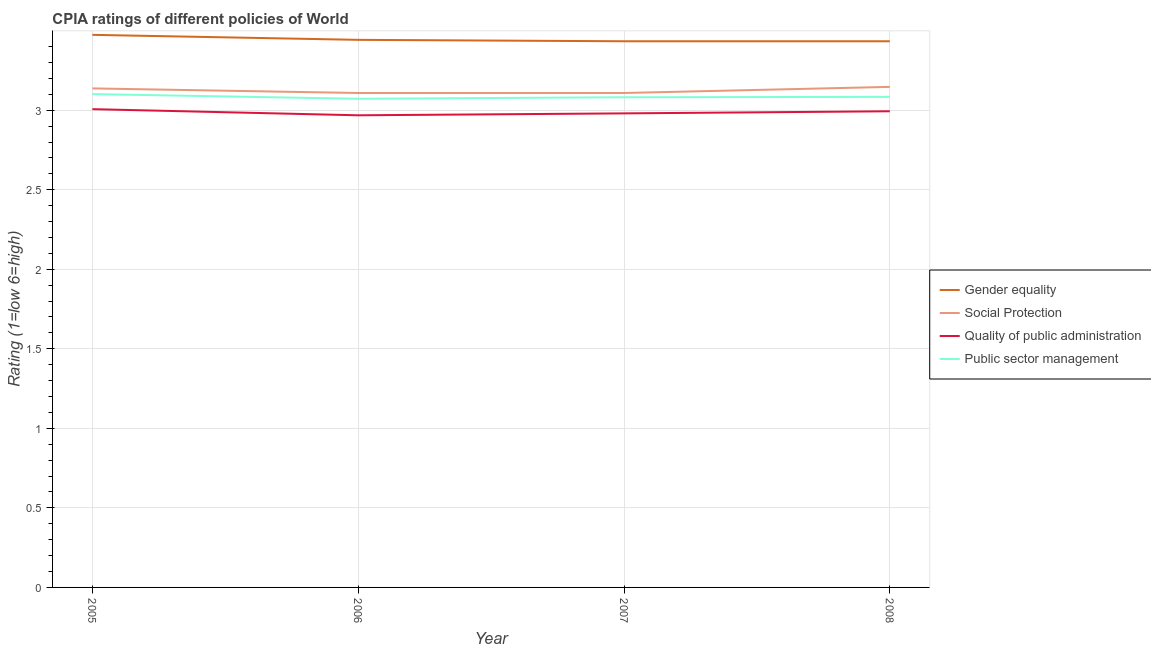How many different coloured lines are there?
Provide a short and direct response. 4. Does the line corresponding to cpia rating of gender equality intersect with the line corresponding to cpia rating of quality of public administration?
Keep it short and to the point. No. Is the number of lines equal to the number of legend labels?
Offer a very short reply. Yes. What is the cpia rating of gender equality in 2007?
Offer a terse response. 3.43. Across all years, what is the maximum cpia rating of public sector management?
Keep it short and to the point. 3.1. Across all years, what is the minimum cpia rating of social protection?
Your answer should be compact. 3.11. In which year was the cpia rating of gender equality maximum?
Your answer should be compact. 2005. What is the total cpia rating of social protection in the graph?
Your response must be concise. 12.5. What is the difference between the cpia rating of gender equality in 2006 and that in 2007?
Your answer should be compact. 0.01. What is the difference between the cpia rating of public sector management in 2005 and the cpia rating of gender equality in 2008?
Provide a succinct answer. -0.33. What is the average cpia rating of quality of public administration per year?
Keep it short and to the point. 2.99. In the year 2006, what is the difference between the cpia rating of quality of public administration and cpia rating of social protection?
Give a very brief answer. -0.14. What is the ratio of the cpia rating of gender equality in 2005 to that in 2008?
Ensure brevity in your answer.  1.01. Is the difference between the cpia rating of public sector management in 2007 and 2008 greater than the difference between the cpia rating of quality of public administration in 2007 and 2008?
Your answer should be very brief. Yes. What is the difference between the highest and the second highest cpia rating of gender equality?
Give a very brief answer. 0.03. What is the difference between the highest and the lowest cpia rating of social protection?
Provide a succinct answer. 0.04. In how many years, is the cpia rating of public sector management greater than the average cpia rating of public sector management taken over all years?
Give a very brief answer. 1. Is it the case that in every year, the sum of the cpia rating of quality of public administration and cpia rating of public sector management is greater than the sum of cpia rating of gender equality and cpia rating of social protection?
Ensure brevity in your answer.  Yes. Is it the case that in every year, the sum of the cpia rating of gender equality and cpia rating of social protection is greater than the cpia rating of quality of public administration?
Provide a succinct answer. Yes. What is the difference between two consecutive major ticks on the Y-axis?
Offer a terse response. 0.5. Does the graph contain any zero values?
Provide a short and direct response. No. Does the graph contain grids?
Your answer should be compact. Yes. Where does the legend appear in the graph?
Give a very brief answer. Center right. What is the title of the graph?
Offer a very short reply. CPIA ratings of different policies of World. Does "Social Protection" appear as one of the legend labels in the graph?
Provide a short and direct response. Yes. What is the label or title of the Y-axis?
Your answer should be very brief. Rating (1=low 6=high). What is the Rating (1=low 6=high) in Gender equality in 2005?
Your answer should be very brief. 3.47. What is the Rating (1=low 6=high) in Social Protection in 2005?
Make the answer very short. 3.14. What is the Rating (1=low 6=high) in Quality of public administration in 2005?
Ensure brevity in your answer.  3.01. What is the Rating (1=low 6=high) in Public sector management in 2005?
Keep it short and to the point. 3.1. What is the Rating (1=low 6=high) in Gender equality in 2006?
Make the answer very short. 3.44. What is the Rating (1=low 6=high) of Social Protection in 2006?
Offer a very short reply. 3.11. What is the Rating (1=low 6=high) in Quality of public administration in 2006?
Your answer should be very brief. 2.97. What is the Rating (1=low 6=high) of Public sector management in 2006?
Give a very brief answer. 3.07. What is the Rating (1=low 6=high) of Gender equality in 2007?
Give a very brief answer. 3.43. What is the Rating (1=low 6=high) of Social Protection in 2007?
Provide a succinct answer. 3.11. What is the Rating (1=low 6=high) in Quality of public administration in 2007?
Give a very brief answer. 2.98. What is the Rating (1=low 6=high) of Public sector management in 2007?
Your answer should be compact. 3.08. What is the Rating (1=low 6=high) in Gender equality in 2008?
Ensure brevity in your answer.  3.43. What is the Rating (1=low 6=high) of Social Protection in 2008?
Ensure brevity in your answer.  3.15. What is the Rating (1=low 6=high) of Quality of public administration in 2008?
Give a very brief answer. 2.99. What is the Rating (1=low 6=high) of Public sector management in 2008?
Make the answer very short. 3.08. Across all years, what is the maximum Rating (1=low 6=high) of Gender equality?
Ensure brevity in your answer.  3.47. Across all years, what is the maximum Rating (1=low 6=high) in Social Protection?
Your answer should be compact. 3.15. Across all years, what is the maximum Rating (1=low 6=high) of Quality of public administration?
Make the answer very short. 3.01. Across all years, what is the maximum Rating (1=low 6=high) of Public sector management?
Provide a succinct answer. 3.1. Across all years, what is the minimum Rating (1=low 6=high) of Gender equality?
Offer a terse response. 3.43. Across all years, what is the minimum Rating (1=low 6=high) of Social Protection?
Make the answer very short. 3.11. Across all years, what is the minimum Rating (1=low 6=high) of Quality of public administration?
Make the answer very short. 2.97. Across all years, what is the minimum Rating (1=low 6=high) in Public sector management?
Your response must be concise. 3.07. What is the total Rating (1=low 6=high) in Gender equality in the graph?
Your response must be concise. 13.78. What is the total Rating (1=low 6=high) of Social Protection in the graph?
Provide a succinct answer. 12.5. What is the total Rating (1=low 6=high) of Quality of public administration in the graph?
Provide a succinct answer. 11.95. What is the total Rating (1=low 6=high) in Public sector management in the graph?
Ensure brevity in your answer.  12.34. What is the difference between the Rating (1=low 6=high) in Gender equality in 2005 and that in 2006?
Offer a terse response. 0.03. What is the difference between the Rating (1=low 6=high) in Social Protection in 2005 and that in 2006?
Offer a very short reply. 0.03. What is the difference between the Rating (1=low 6=high) in Quality of public administration in 2005 and that in 2006?
Provide a short and direct response. 0.04. What is the difference between the Rating (1=low 6=high) of Public sector management in 2005 and that in 2006?
Give a very brief answer. 0.03. What is the difference between the Rating (1=low 6=high) in Gender equality in 2005 and that in 2007?
Offer a very short reply. 0.04. What is the difference between the Rating (1=low 6=high) in Social Protection in 2005 and that in 2007?
Make the answer very short. 0.03. What is the difference between the Rating (1=low 6=high) of Quality of public administration in 2005 and that in 2007?
Your answer should be compact. 0.03. What is the difference between the Rating (1=low 6=high) in Public sector management in 2005 and that in 2007?
Offer a very short reply. 0.02. What is the difference between the Rating (1=low 6=high) of Gender equality in 2005 and that in 2008?
Your answer should be compact. 0.04. What is the difference between the Rating (1=low 6=high) in Social Protection in 2005 and that in 2008?
Ensure brevity in your answer.  -0.01. What is the difference between the Rating (1=low 6=high) in Quality of public administration in 2005 and that in 2008?
Offer a terse response. 0.01. What is the difference between the Rating (1=low 6=high) in Public sector management in 2005 and that in 2008?
Your answer should be very brief. 0.02. What is the difference between the Rating (1=low 6=high) of Gender equality in 2006 and that in 2007?
Keep it short and to the point. 0.01. What is the difference between the Rating (1=low 6=high) of Quality of public administration in 2006 and that in 2007?
Your response must be concise. -0.01. What is the difference between the Rating (1=low 6=high) of Public sector management in 2006 and that in 2007?
Make the answer very short. -0.01. What is the difference between the Rating (1=low 6=high) in Gender equality in 2006 and that in 2008?
Your answer should be compact. 0.01. What is the difference between the Rating (1=low 6=high) of Social Protection in 2006 and that in 2008?
Your response must be concise. -0.04. What is the difference between the Rating (1=low 6=high) in Quality of public administration in 2006 and that in 2008?
Provide a short and direct response. -0.03. What is the difference between the Rating (1=low 6=high) in Public sector management in 2006 and that in 2008?
Provide a short and direct response. -0.01. What is the difference between the Rating (1=low 6=high) of Gender equality in 2007 and that in 2008?
Ensure brevity in your answer.  0. What is the difference between the Rating (1=low 6=high) of Social Protection in 2007 and that in 2008?
Provide a short and direct response. -0.04. What is the difference between the Rating (1=low 6=high) of Quality of public administration in 2007 and that in 2008?
Offer a terse response. -0.01. What is the difference between the Rating (1=low 6=high) in Public sector management in 2007 and that in 2008?
Provide a short and direct response. -0. What is the difference between the Rating (1=low 6=high) of Gender equality in 2005 and the Rating (1=low 6=high) of Social Protection in 2006?
Provide a short and direct response. 0.37. What is the difference between the Rating (1=low 6=high) of Gender equality in 2005 and the Rating (1=low 6=high) of Quality of public administration in 2006?
Ensure brevity in your answer.  0.51. What is the difference between the Rating (1=low 6=high) in Gender equality in 2005 and the Rating (1=low 6=high) in Public sector management in 2006?
Your answer should be very brief. 0.4. What is the difference between the Rating (1=low 6=high) of Social Protection in 2005 and the Rating (1=low 6=high) of Quality of public administration in 2006?
Your response must be concise. 0.17. What is the difference between the Rating (1=low 6=high) in Social Protection in 2005 and the Rating (1=low 6=high) in Public sector management in 2006?
Give a very brief answer. 0.07. What is the difference between the Rating (1=low 6=high) in Quality of public administration in 2005 and the Rating (1=low 6=high) in Public sector management in 2006?
Your answer should be very brief. -0.07. What is the difference between the Rating (1=low 6=high) in Gender equality in 2005 and the Rating (1=low 6=high) in Social Protection in 2007?
Ensure brevity in your answer.  0.37. What is the difference between the Rating (1=low 6=high) in Gender equality in 2005 and the Rating (1=low 6=high) in Quality of public administration in 2007?
Provide a succinct answer. 0.49. What is the difference between the Rating (1=low 6=high) in Gender equality in 2005 and the Rating (1=low 6=high) in Public sector management in 2007?
Provide a short and direct response. 0.39. What is the difference between the Rating (1=low 6=high) in Social Protection in 2005 and the Rating (1=low 6=high) in Quality of public administration in 2007?
Your answer should be very brief. 0.16. What is the difference between the Rating (1=low 6=high) in Social Protection in 2005 and the Rating (1=low 6=high) in Public sector management in 2007?
Make the answer very short. 0.06. What is the difference between the Rating (1=low 6=high) in Quality of public administration in 2005 and the Rating (1=low 6=high) in Public sector management in 2007?
Provide a short and direct response. -0.07. What is the difference between the Rating (1=low 6=high) in Gender equality in 2005 and the Rating (1=low 6=high) in Social Protection in 2008?
Keep it short and to the point. 0.33. What is the difference between the Rating (1=low 6=high) of Gender equality in 2005 and the Rating (1=low 6=high) of Quality of public administration in 2008?
Give a very brief answer. 0.48. What is the difference between the Rating (1=low 6=high) in Gender equality in 2005 and the Rating (1=low 6=high) in Public sector management in 2008?
Your answer should be compact. 0.39. What is the difference between the Rating (1=low 6=high) in Social Protection in 2005 and the Rating (1=low 6=high) in Quality of public administration in 2008?
Your response must be concise. 0.14. What is the difference between the Rating (1=low 6=high) in Social Protection in 2005 and the Rating (1=low 6=high) in Public sector management in 2008?
Provide a short and direct response. 0.05. What is the difference between the Rating (1=low 6=high) in Quality of public administration in 2005 and the Rating (1=low 6=high) in Public sector management in 2008?
Ensure brevity in your answer.  -0.08. What is the difference between the Rating (1=low 6=high) of Gender equality in 2006 and the Rating (1=low 6=high) of Social Protection in 2007?
Offer a very short reply. 0.33. What is the difference between the Rating (1=low 6=high) in Gender equality in 2006 and the Rating (1=low 6=high) in Quality of public administration in 2007?
Offer a very short reply. 0.46. What is the difference between the Rating (1=low 6=high) of Gender equality in 2006 and the Rating (1=low 6=high) of Public sector management in 2007?
Give a very brief answer. 0.36. What is the difference between the Rating (1=low 6=high) of Social Protection in 2006 and the Rating (1=low 6=high) of Quality of public administration in 2007?
Offer a terse response. 0.13. What is the difference between the Rating (1=low 6=high) of Social Protection in 2006 and the Rating (1=low 6=high) of Public sector management in 2007?
Provide a short and direct response. 0.03. What is the difference between the Rating (1=low 6=high) in Quality of public administration in 2006 and the Rating (1=low 6=high) in Public sector management in 2007?
Offer a terse response. -0.11. What is the difference between the Rating (1=low 6=high) in Gender equality in 2006 and the Rating (1=low 6=high) in Social Protection in 2008?
Offer a very short reply. 0.3. What is the difference between the Rating (1=low 6=high) in Gender equality in 2006 and the Rating (1=low 6=high) in Quality of public administration in 2008?
Give a very brief answer. 0.45. What is the difference between the Rating (1=low 6=high) in Gender equality in 2006 and the Rating (1=low 6=high) in Public sector management in 2008?
Your answer should be very brief. 0.36. What is the difference between the Rating (1=low 6=high) in Social Protection in 2006 and the Rating (1=low 6=high) in Quality of public administration in 2008?
Offer a very short reply. 0.11. What is the difference between the Rating (1=low 6=high) in Social Protection in 2006 and the Rating (1=low 6=high) in Public sector management in 2008?
Keep it short and to the point. 0.02. What is the difference between the Rating (1=low 6=high) in Quality of public administration in 2006 and the Rating (1=low 6=high) in Public sector management in 2008?
Provide a succinct answer. -0.12. What is the difference between the Rating (1=low 6=high) in Gender equality in 2007 and the Rating (1=low 6=high) in Social Protection in 2008?
Ensure brevity in your answer.  0.29. What is the difference between the Rating (1=low 6=high) in Gender equality in 2007 and the Rating (1=low 6=high) in Quality of public administration in 2008?
Ensure brevity in your answer.  0.44. What is the difference between the Rating (1=low 6=high) of Gender equality in 2007 and the Rating (1=low 6=high) of Public sector management in 2008?
Your response must be concise. 0.35. What is the difference between the Rating (1=low 6=high) in Social Protection in 2007 and the Rating (1=low 6=high) in Quality of public administration in 2008?
Your response must be concise. 0.11. What is the difference between the Rating (1=low 6=high) in Social Protection in 2007 and the Rating (1=low 6=high) in Public sector management in 2008?
Give a very brief answer. 0.02. What is the difference between the Rating (1=low 6=high) in Quality of public administration in 2007 and the Rating (1=low 6=high) in Public sector management in 2008?
Ensure brevity in your answer.  -0.1. What is the average Rating (1=low 6=high) in Gender equality per year?
Give a very brief answer. 3.45. What is the average Rating (1=low 6=high) of Social Protection per year?
Ensure brevity in your answer.  3.12. What is the average Rating (1=low 6=high) of Quality of public administration per year?
Provide a succinct answer. 2.99. What is the average Rating (1=low 6=high) in Public sector management per year?
Provide a succinct answer. 3.08. In the year 2005, what is the difference between the Rating (1=low 6=high) of Gender equality and Rating (1=low 6=high) of Social Protection?
Provide a short and direct response. 0.34. In the year 2005, what is the difference between the Rating (1=low 6=high) in Gender equality and Rating (1=low 6=high) in Quality of public administration?
Offer a very short reply. 0.47. In the year 2005, what is the difference between the Rating (1=low 6=high) in Gender equality and Rating (1=low 6=high) in Public sector management?
Ensure brevity in your answer.  0.37. In the year 2005, what is the difference between the Rating (1=low 6=high) in Social Protection and Rating (1=low 6=high) in Quality of public administration?
Keep it short and to the point. 0.13. In the year 2005, what is the difference between the Rating (1=low 6=high) in Social Protection and Rating (1=low 6=high) in Public sector management?
Your answer should be very brief. 0.04. In the year 2005, what is the difference between the Rating (1=low 6=high) of Quality of public administration and Rating (1=low 6=high) of Public sector management?
Provide a succinct answer. -0.09. In the year 2006, what is the difference between the Rating (1=low 6=high) in Gender equality and Rating (1=low 6=high) in Social Protection?
Offer a very short reply. 0.33. In the year 2006, what is the difference between the Rating (1=low 6=high) of Gender equality and Rating (1=low 6=high) of Quality of public administration?
Make the answer very short. 0.47. In the year 2006, what is the difference between the Rating (1=low 6=high) in Gender equality and Rating (1=low 6=high) in Public sector management?
Give a very brief answer. 0.37. In the year 2006, what is the difference between the Rating (1=low 6=high) in Social Protection and Rating (1=low 6=high) in Quality of public administration?
Your answer should be compact. 0.14. In the year 2006, what is the difference between the Rating (1=low 6=high) in Social Protection and Rating (1=low 6=high) in Public sector management?
Offer a terse response. 0.04. In the year 2006, what is the difference between the Rating (1=low 6=high) in Quality of public administration and Rating (1=low 6=high) in Public sector management?
Ensure brevity in your answer.  -0.1. In the year 2007, what is the difference between the Rating (1=low 6=high) in Gender equality and Rating (1=low 6=high) in Social Protection?
Your response must be concise. 0.33. In the year 2007, what is the difference between the Rating (1=low 6=high) in Gender equality and Rating (1=low 6=high) in Quality of public administration?
Make the answer very short. 0.45. In the year 2007, what is the difference between the Rating (1=low 6=high) of Gender equality and Rating (1=low 6=high) of Public sector management?
Ensure brevity in your answer.  0.35. In the year 2007, what is the difference between the Rating (1=low 6=high) of Social Protection and Rating (1=low 6=high) of Quality of public administration?
Provide a short and direct response. 0.13. In the year 2007, what is the difference between the Rating (1=low 6=high) of Social Protection and Rating (1=low 6=high) of Public sector management?
Provide a short and direct response. 0.03. In the year 2007, what is the difference between the Rating (1=low 6=high) of Quality of public administration and Rating (1=low 6=high) of Public sector management?
Provide a short and direct response. -0.1. In the year 2008, what is the difference between the Rating (1=low 6=high) in Gender equality and Rating (1=low 6=high) in Social Protection?
Provide a short and direct response. 0.29. In the year 2008, what is the difference between the Rating (1=low 6=high) of Gender equality and Rating (1=low 6=high) of Quality of public administration?
Give a very brief answer. 0.44. In the year 2008, what is the difference between the Rating (1=low 6=high) in Gender equality and Rating (1=low 6=high) in Public sector management?
Provide a short and direct response. 0.35. In the year 2008, what is the difference between the Rating (1=low 6=high) in Social Protection and Rating (1=low 6=high) in Quality of public administration?
Offer a terse response. 0.15. In the year 2008, what is the difference between the Rating (1=low 6=high) of Social Protection and Rating (1=low 6=high) of Public sector management?
Keep it short and to the point. 0.06. In the year 2008, what is the difference between the Rating (1=low 6=high) in Quality of public administration and Rating (1=low 6=high) in Public sector management?
Provide a succinct answer. -0.09. What is the ratio of the Rating (1=low 6=high) of Gender equality in 2005 to that in 2006?
Your answer should be compact. 1.01. What is the ratio of the Rating (1=low 6=high) of Social Protection in 2005 to that in 2006?
Make the answer very short. 1.01. What is the ratio of the Rating (1=low 6=high) of Quality of public administration in 2005 to that in 2006?
Your answer should be very brief. 1.01. What is the ratio of the Rating (1=low 6=high) of Public sector management in 2005 to that in 2006?
Make the answer very short. 1.01. What is the ratio of the Rating (1=low 6=high) in Gender equality in 2005 to that in 2007?
Your answer should be compact. 1.01. What is the ratio of the Rating (1=low 6=high) in Social Protection in 2005 to that in 2007?
Keep it short and to the point. 1.01. What is the ratio of the Rating (1=low 6=high) of Quality of public administration in 2005 to that in 2007?
Make the answer very short. 1.01. What is the ratio of the Rating (1=low 6=high) in Gender equality in 2005 to that in 2008?
Your answer should be very brief. 1.01. What is the ratio of the Rating (1=low 6=high) of Social Protection in 2005 to that in 2008?
Offer a terse response. 1. What is the ratio of the Rating (1=low 6=high) in Public sector management in 2005 to that in 2008?
Give a very brief answer. 1.01. What is the ratio of the Rating (1=low 6=high) in Gender equality in 2006 to that in 2007?
Provide a succinct answer. 1. What is the ratio of the Rating (1=low 6=high) of Social Protection in 2006 to that in 2008?
Ensure brevity in your answer.  0.99. What is the ratio of the Rating (1=low 6=high) in Public sector management in 2006 to that in 2008?
Provide a short and direct response. 1. What is the ratio of the Rating (1=low 6=high) of Gender equality in 2007 to that in 2008?
Make the answer very short. 1. What is the ratio of the Rating (1=low 6=high) in Quality of public administration in 2007 to that in 2008?
Offer a very short reply. 1. What is the ratio of the Rating (1=low 6=high) in Public sector management in 2007 to that in 2008?
Ensure brevity in your answer.  1. What is the difference between the highest and the second highest Rating (1=low 6=high) of Gender equality?
Make the answer very short. 0.03. What is the difference between the highest and the second highest Rating (1=low 6=high) in Social Protection?
Give a very brief answer. 0.01. What is the difference between the highest and the second highest Rating (1=low 6=high) in Quality of public administration?
Provide a short and direct response. 0.01. What is the difference between the highest and the second highest Rating (1=low 6=high) of Public sector management?
Offer a terse response. 0.02. What is the difference between the highest and the lowest Rating (1=low 6=high) in Gender equality?
Your answer should be very brief. 0.04. What is the difference between the highest and the lowest Rating (1=low 6=high) of Social Protection?
Offer a terse response. 0.04. What is the difference between the highest and the lowest Rating (1=low 6=high) in Quality of public administration?
Offer a very short reply. 0.04. What is the difference between the highest and the lowest Rating (1=low 6=high) of Public sector management?
Provide a succinct answer. 0.03. 